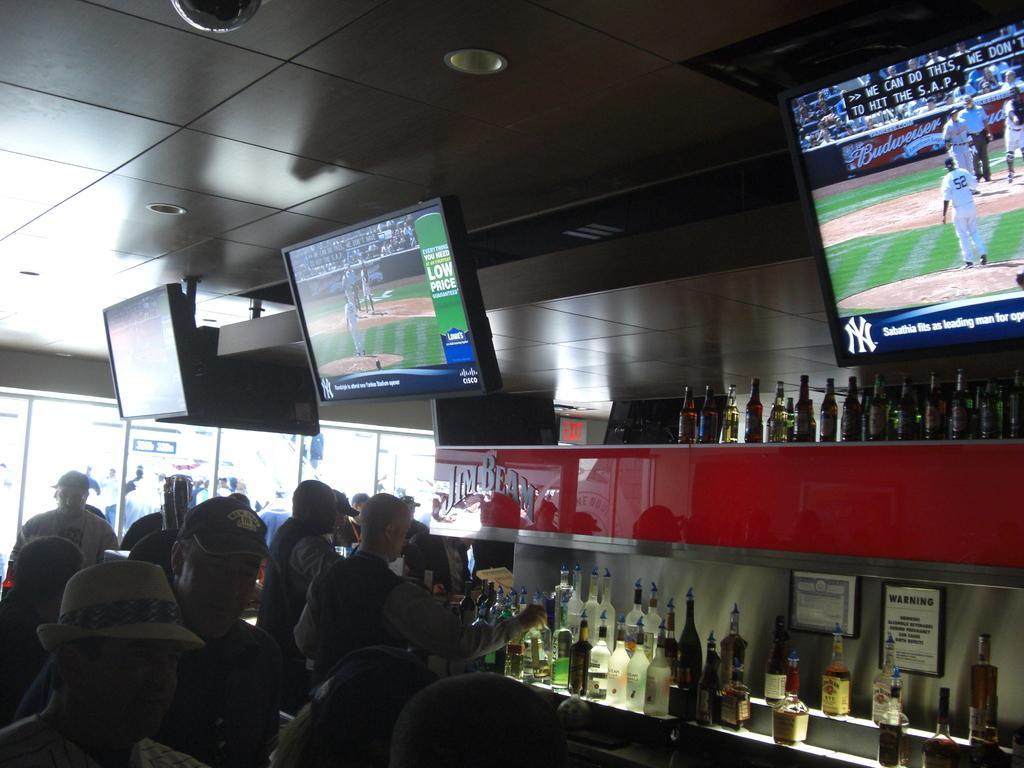How would you summarize this image in a sentence or two? On the left side of the image there few people standing. On the right side there is a rack. On the rack there are few bottles are arranged. At the top of the image there is a ceiling and some monitors are attached to it. 